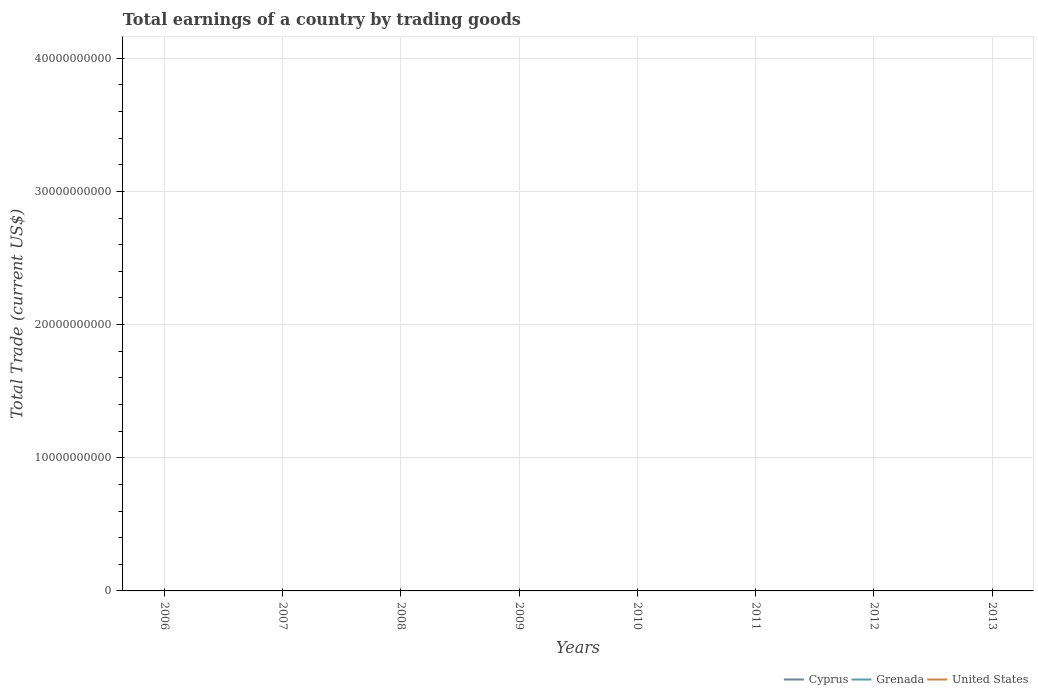Is the number of lines equal to the number of legend labels?
Your answer should be compact. No. Across all years, what is the maximum total earnings in Grenada?
Keep it short and to the point. 0. Is the total earnings in Grenada strictly greater than the total earnings in Cyprus over the years?
Give a very brief answer. No. How many years are there in the graph?
Ensure brevity in your answer.  8. Does the graph contain any zero values?
Your answer should be compact. Yes. What is the title of the graph?
Provide a succinct answer. Total earnings of a country by trading goods. Does "Least developed countries" appear as one of the legend labels in the graph?
Provide a short and direct response. No. What is the label or title of the X-axis?
Your response must be concise. Years. What is the label or title of the Y-axis?
Offer a very short reply. Total Trade (current US$). What is the Total Trade (current US$) of Cyprus in 2006?
Your answer should be compact. 0. What is the Total Trade (current US$) of Grenada in 2006?
Your answer should be compact. 0. What is the Total Trade (current US$) in Cyprus in 2007?
Your response must be concise. 0. What is the Total Trade (current US$) of United States in 2007?
Keep it short and to the point. 0. What is the Total Trade (current US$) in Cyprus in 2008?
Ensure brevity in your answer.  0. What is the Total Trade (current US$) of Grenada in 2008?
Ensure brevity in your answer.  0. What is the Total Trade (current US$) of Cyprus in 2009?
Offer a terse response. 0. What is the Total Trade (current US$) of Grenada in 2009?
Provide a succinct answer. 0. What is the Total Trade (current US$) in Cyprus in 2010?
Your response must be concise. 0. What is the Total Trade (current US$) in Cyprus in 2011?
Keep it short and to the point. 0. What is the Total Trade (current US$) of Grenada in 2011?
Offer a very short reply. 0. What is the Total Trade (current US$) of Cyprus in 2012?
Give a very brief answer. 0. What is the Total Trade (current US$) in Cyprus in 2013?
Keep it short and to the point. 0. What is the total Total Trade (current US$) in Grenada in the graph?
Give a very brief answer. 0. What is the total Total Trade (current US$) in United States in the graph?
Keep it short and to the point. 0. What is the average Total Trade (current US$) in Grenada per year?
Your answer should be very brief. 0. 